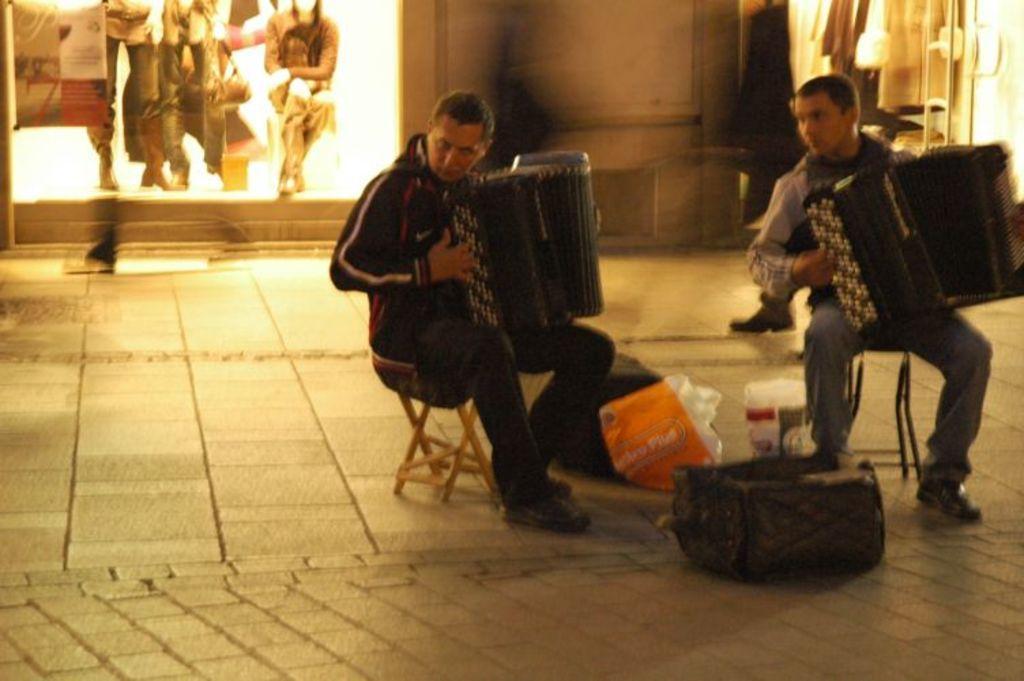Please provide a concise description of this image. In this image we can see two men sitting on the chairs and holding holding accordions in their hands. On the floor we can see polythene covers and bags. In the background we can see electric lights, advertisements and mannequins. 